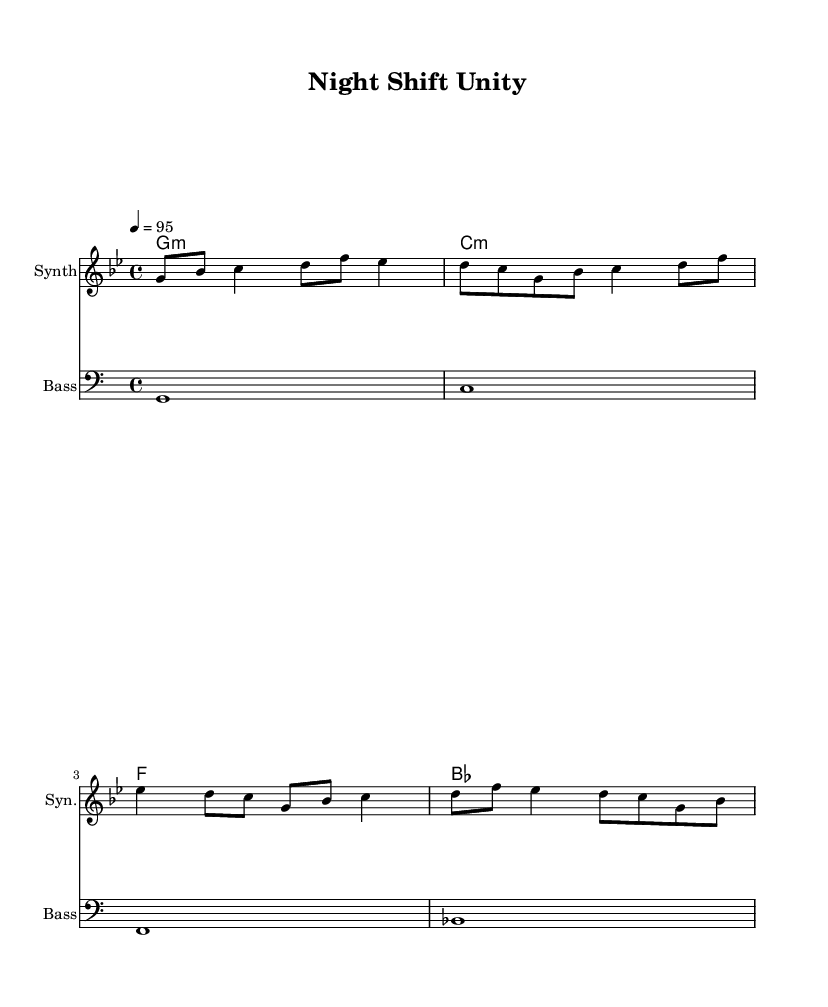What is the key signature of this music? The key signature in this piece is G minor, which is indicated by the presence of two flats (B flat and E flat). This can be identified from the context of the music sheet where it specifies the key signature at the beginning.
Answer: G minor What is the time signature of this music? The time signature shown is 4/4, which means there are four beats in each measure and the quarter note gets one beat. This is reflected in the notation right next to the clef at the start of the music.
Answer: 4/4 What is the tempo marking for this piece? The tempo marking indicates that the piece should be played at a speed of 95 beats per minute, which sets the pace for how quickly the music should be performed. This can be found in the tempo indication found in the header of the sheet music.
Answer: 95 What type of instruments are used in this score? There are two types of instruments indicated in the score: a synthesizer and a bass. This information can be located in the instrument names listed above each staff in the music sheet.
Answer: Synthesizer and Bass How many measures are in the melody section? The melody section consists of four measures. By counting the vertical lines separating the notes, which indicates the ends of each measure, we can confirm that there are indeed four measures present in the melody part.
Answer: Four What harmonic progression is indicated in this music? The harmonic progression indicated follows a sequence of G minor, C minor, F, and B flat. This can be deduced by looking at the chord symbols written above the melody line, showing the progression that accompanies the melody throughout the piece.
Answer: G minor, C minor, F, B flat What is a key theme celebrated in this upbeat hip-hop track? The key theme celebrated in this track is cultural diversity in the workplace. This can be inferred from the title "Night Shift Unity," which suggests a focus on unity and collaboration among diverse workers during night shifts.
Answer: Cultural diversity 